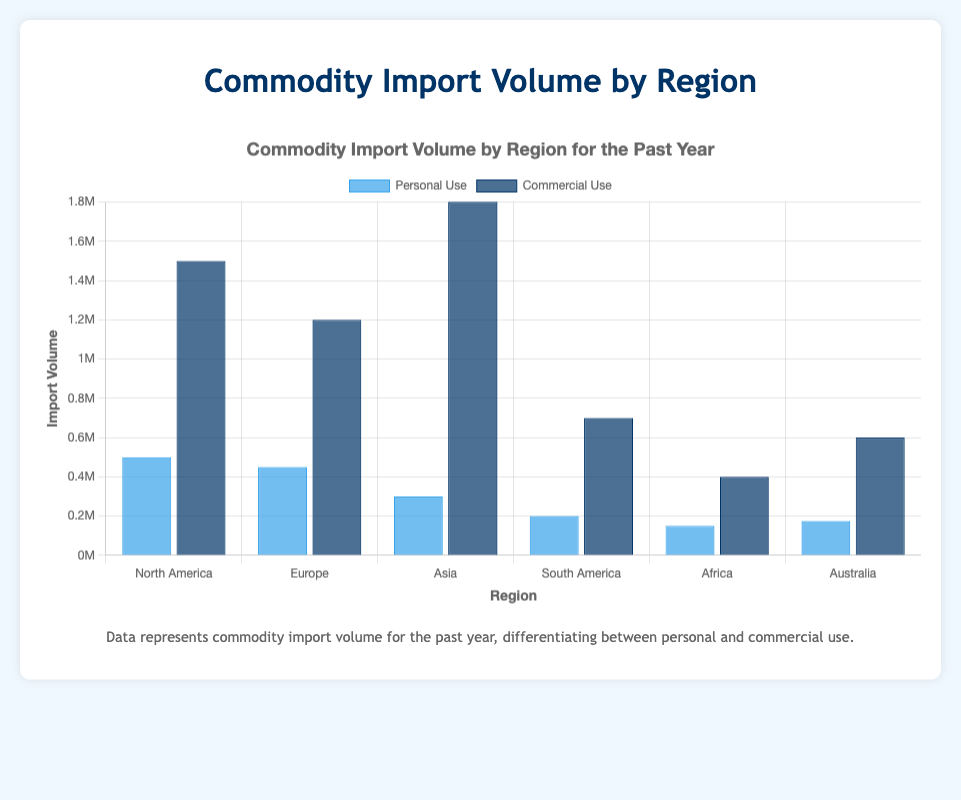Which region has the highest total import volume? To find the region with the highest total import volume, you need to sum the volumes of personal and commercial use for each region. North America: 500,000 + 1,500,000 = 2,000,000; Europe: 450,000 + 1,200,000 = 1,650,000; Asia: 300,000 + 1,800,000 = 2,100,000; South America: 200,000 + 700,000 = 900,000; Africa: 150,000 + 400,000 = 550,000; Australia: 175,000 + 600,000 = 775,000. Asia has the highest total import volume.
Answer: Asia Which region has the smallest difference between personal and commercial use import volumes? To determine the smallest difference between personal and commercial use, calculate the absolute difference for each region. North America: 1,500,000 - 500,000 = 1,000,000; Europe: 1,200,000 - 450,000 = 750,000; Asia: 1,800,000 - 300,000 = 1,500,000; South America: 700,000 - 200,000 = 500,000; Africa: 400,000 - 150,000 = 250,000; Australia: 600,000 - 175,000 = 425,000. Africa has the smallest difference.
Answer: Africa What is the total import volume for South America? To find the total import volume for South America, add the volumes of personal and commercial use. 200,000 + 700,000 = 900,000.
Answer: 900,000 Which two regions have similar volumes for personal use imports? By comparing the volumes of personal use, North America: 500,000; Europe: 450,000; Asia: 300,000; South America: 200,000; Africa: 150,000; Australia: 175,000. The values for Europe and North America are relatively close: 450,000 and 500,000.
Answer: North America, Europe In which region is the proportion of commercial use to the total volume the highest? For each region, calculate the proportion of commercial use to the total volume (personal use + commercial use). North America: 1,500,000 / 2,000,000 = 0.75; Europe: 1,200,000 / 1,650,000 = 0.7273; Asia: 1,800,000 / 2,100,000 = 0.8571; South America: 700,000 / 900,000 = 0.7778; Africa: 400,000 / 550,000 = 0.7273; Australia: 600,000 / 775,000 = 0.7742. Asia has the highest proportion.
Answer: Asia Which region has the lowest personal use import volume? Comparing the personal use import volumes: North America: 500,000; Europe: 450,000; Asia: 300,000; South America: 200,000; Africa: 150,000; Australia: 175,000. Africa has the lowest personal use import volume.
Answer: Africa How many regions have a commercial use import volume exceeding 1,000,000? By looking at the commercial use volumes: North America: 1,500,000; Europe: 1,200,000; Asia: 1,800,000; South America: 700,000; Africa: 400,000; Australia: 600,000. Three regions have a commercial use volume exceeding 1,000,000: North America, Europe, and Asia.
Answer: 3 What is the combined import volume for North America and Europe in both personal and commercial use? To find the combined import volume, add the personal and commercial use volumes for North America and Europe. North America: 500,000 + 1,500,000 = 2,000,000; Europe: 450,000 + 1,200,000 = 1,650,000. Combined total: 2,000,000 + 1,650,000 = 3,650,000.
Answer: 3,650,000 Which use type (personal or commercial) has a greater variance across the regions? To identify which use type has greater variance, you need to visually or mathematically inspect the spread of import volumes for personal and commercial use across the regions. The commercial use volumes vary from 400,000 to 1,800,000, while personal use volumes vary from 150,000 to 500,000. The commercial use has a greater variance.
Answer: Commercial Use 